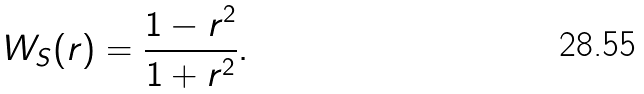Convert formula to latex. <formula><loc_0><loc_0><loc_500><loc_500>W _ { S } ( r ) = \frac { 1 - r ^ { 2 } } { 1 + r ^ { 2 } } .</formula> 